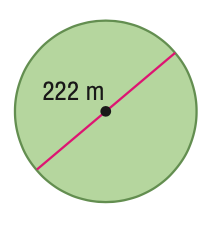Answer the mathemtical geometry problem and directly provide the correct option letter.
Question: Find the area of the circle. Round to the nearest tenth.
Choices: A: 348.7 B: 697.4 C: 38707.6 D: 154830.3 C 